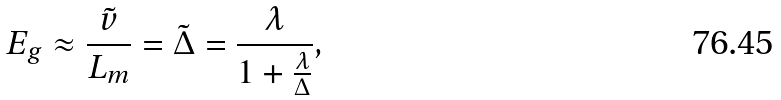Convert formula to latex. <formula><loc_0><loc_0><loc_500><loc_500>E _ { g } \approx \frac { \tilde { v } } { L _ { m } } = \tilde { \Delta } = \frac { \lambda } { 1 + \frac { \lambda } { \Delta } } ,</formula> 